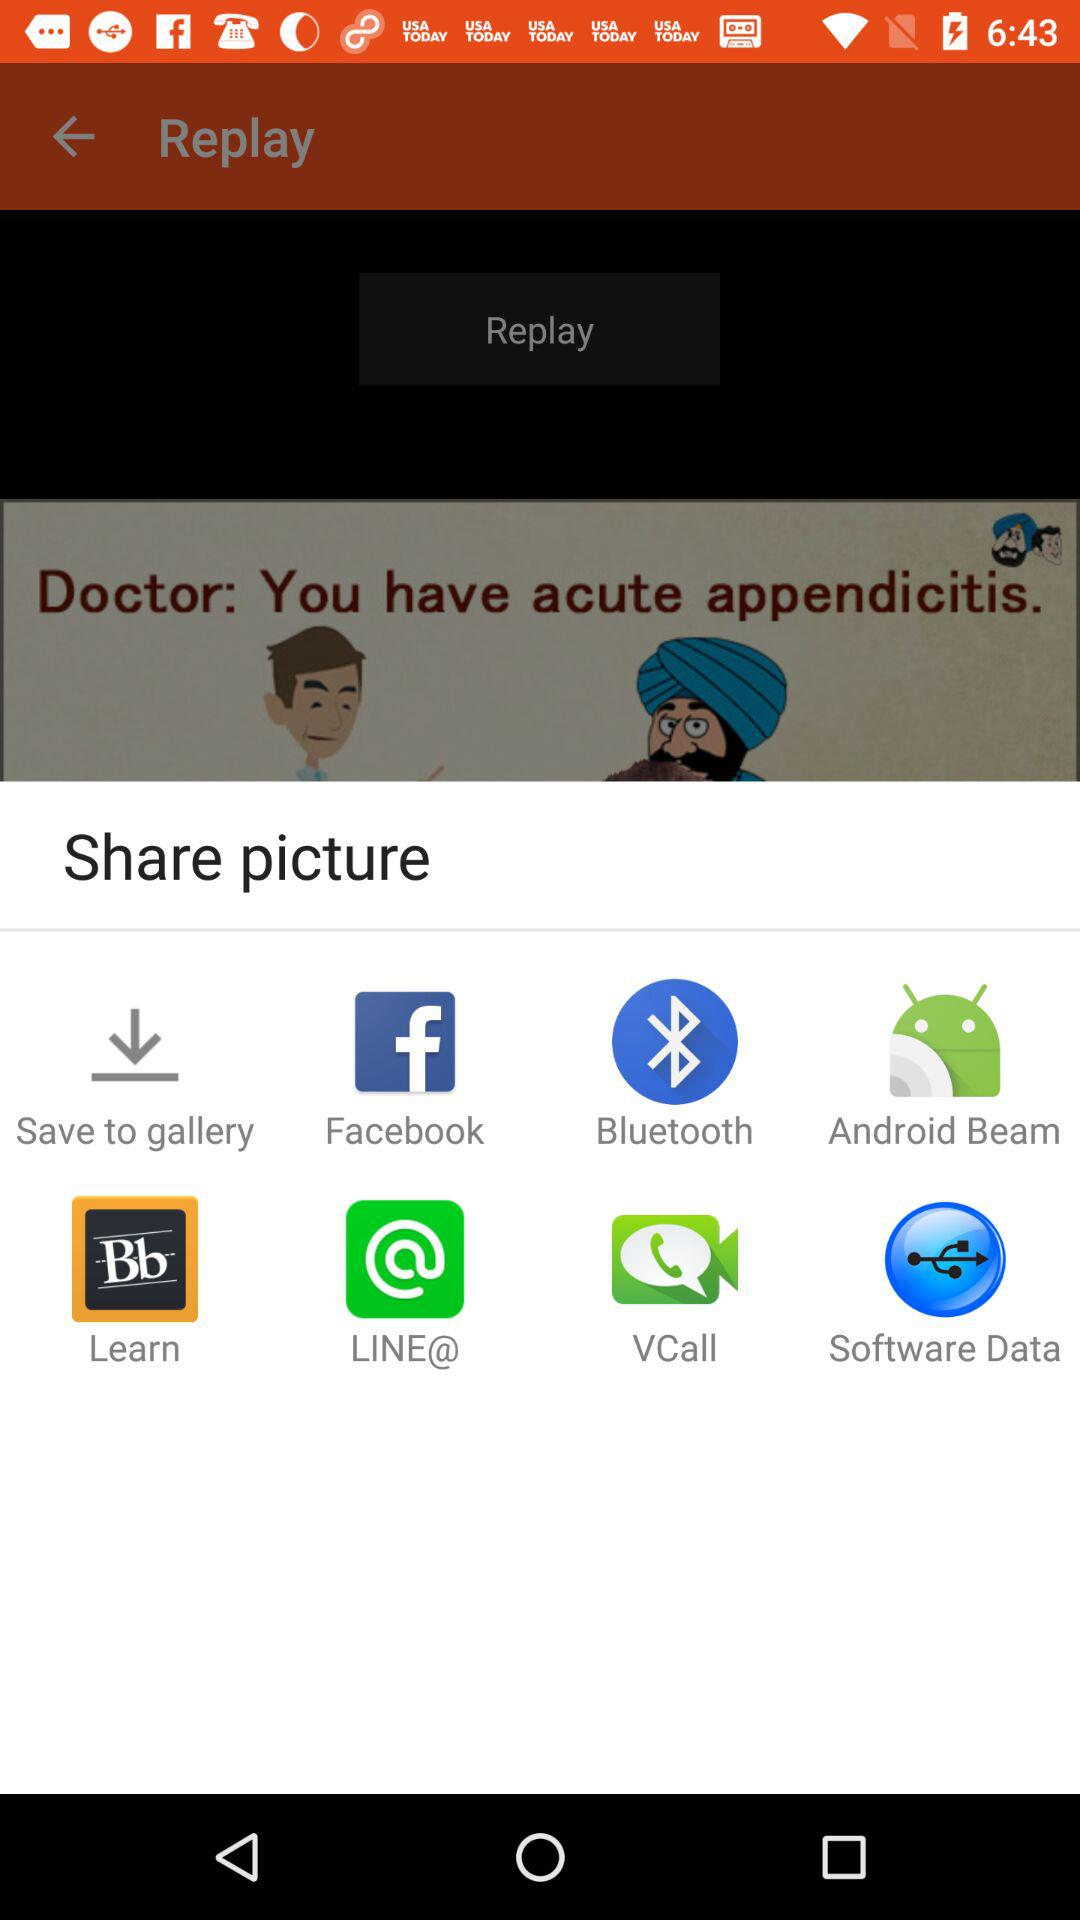What are the different options available for sharing the picture? The different available options are "Save to gallery", "Facebook", "Bluetooth", "Android Beam", "Learn", "LINE@", "VCall" and "Software Data". 